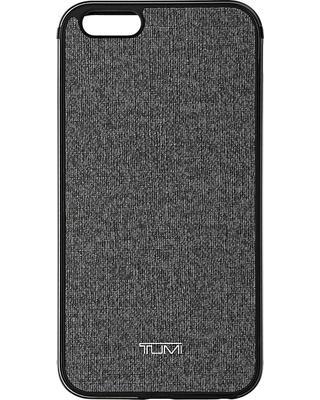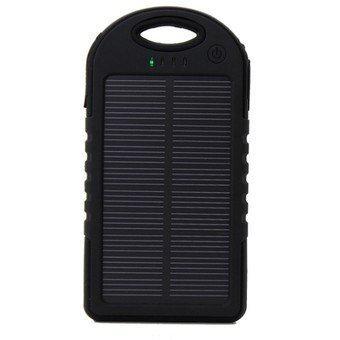The first image is the image on the left, the second image is the image on the right. Given the left and right images, does the statement "There is a colorful remote control with non-grid buttons in one image, and a black piece of electronics in the other." hold true? Answer yes or no. No. The first image is the image on the left, the second image is the image on the right. Given the left and right images, does the statement "There are two phones and one of them is ovalish." hold true? Answer yes or no. No. 